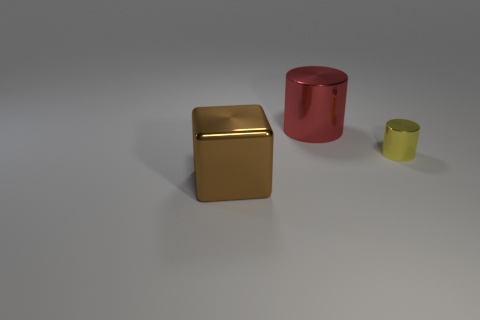Are there any other things that are the same size as the yellow shiny thing?
Provide a short and direct response. No. What is the size of the thing that is on the right side of the large object that is right of the big brown object?
Keep it short and to the point. Small. There is a large thing that is in front of the large thing that is behind the metal thing that is left of the red thing; what is its shape?
Ensure brevity in your answer.  Cube. What is the color of the large cube that is the same material as the big red cylinder?
Provide a succinct answer. Brown. There is a cylinder behind the metal object to the right of the big metallic object behind the tiny cylinder; what is its color?
Your response must be concise. Red. What number of blocks are metal things or large red metal objects?
Provide a short and direct response. 1. The large metal block has what color?
Ensure brevity in your answer.  Brown. What number of things are small metal objects or tiny cyan matte cylinders?
Provide a succinct answer. 1. There is a shiny cube that is to the left of the large red metallic cylinder; what is its size?
Provide a short and direct response. Large. What number of objects are big shiny cubes that are to the left of the large metal cylinder or metal objects left of the large red cylinder?
Make the answer very short. 1. 